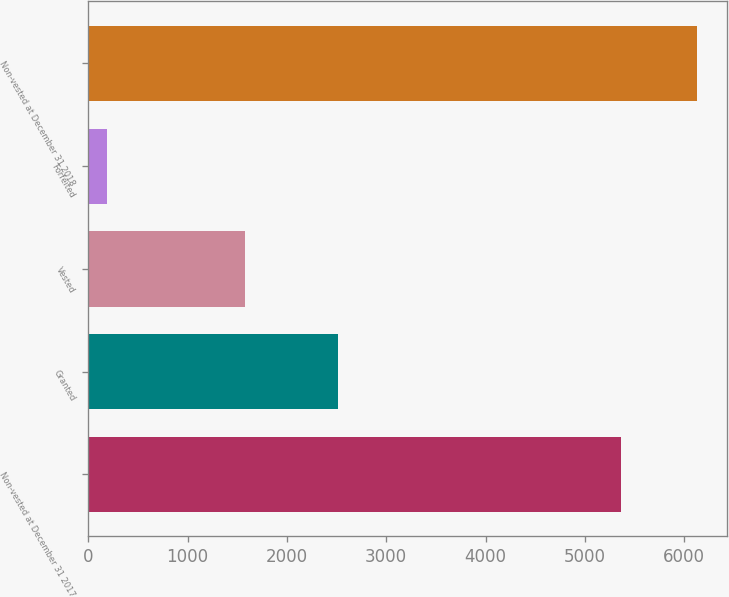<chart> <loc_0><loc_0><loc_500><loc_500><bar_chart><fcel>Non-vested at December 31 2017<fcel>Granted<fcel>Vested<fcel>Forfeited<fcel>Non-vested at December 31 2018<nl><fcel>5367<fcel>2518<fcel>1575<fcel>185<fcel>6125<nl></chart> 